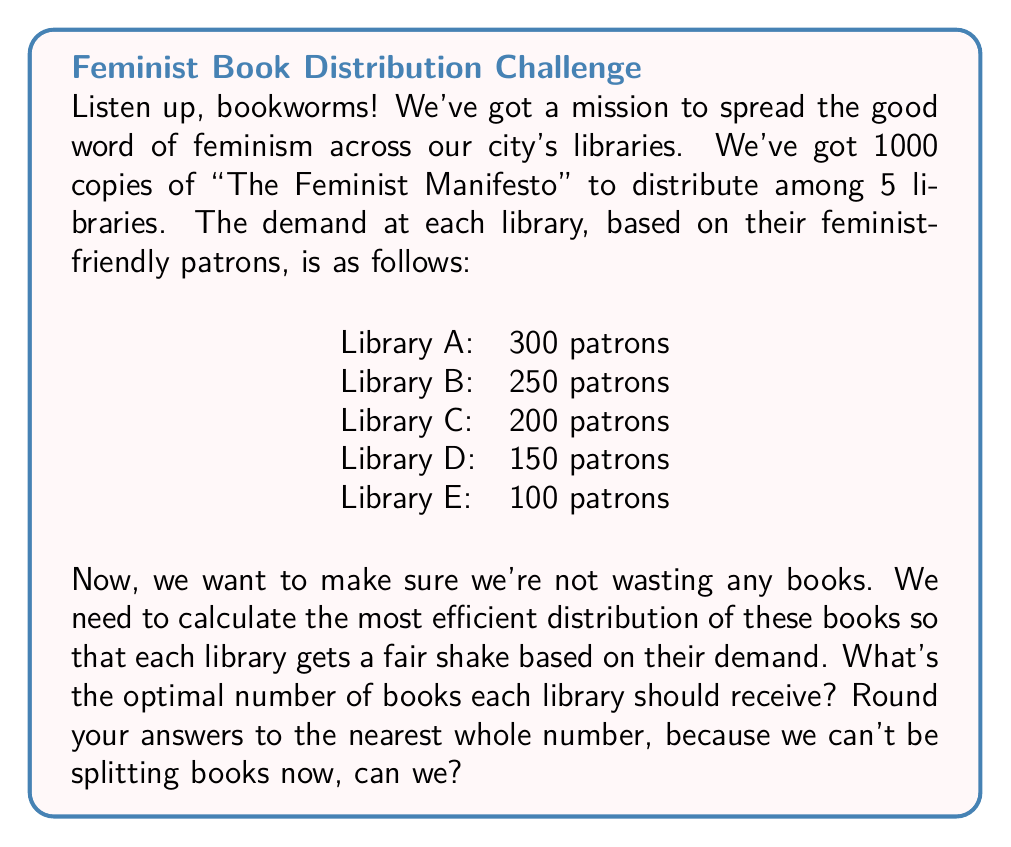Can you answer this question? Alright, let's break this down step by step:

1) First, we need to calculate the total number of patrons across all libraries:

   $300 + 250 + 200 + 150 + 100 = 1000$ patrons

2) Now, we need to determine what fraction of the total patron population each library represents. We'll do this by dividing each library's patron count by the total:

   Library A: $\frac{300}{1000} = 0.3$ or 30%
   Library B: $\frac{250}{1000} = 0.25$ or 25%
   Library C: $\frac{200}{1000} = 0.2$ or 20%
   Library D: $\frac{150}{1000} = 0.15$ or 15%
   Library E: $\frac{100}{1000} = 0.1$ or 10%

3) The most efficient distribution would be to allocate books in proportion to each library's share of the total patron population. We can calculate this by multiplying the total number of books (1000) by each library's fraction:

   Library A: $1000 \times 0.3 = 300$ books
   Library B: $1000 \times 0.25 = 250$ books
   Library C: $1000 \times 0.2 = 200$ books
   Library D: $1000 \times 0.15 = 150$ books
   Library E: $1000 \times 0.1 = 100$ books

4) We don't need to round these numbers because they all worked out to whole numbers. If they hadn't, we would round to the nearest whole number as requested.

5) Let's verify that our distribution adds up to the total number of books:

   $300 + 250 + 200 + 150 + 100 = 1000$ books

This distribution ensures that each library receives a number of books proportional to its demand, maximizing the efficiency of our feminist literature distribution!
Answer: The optimal distribution of books is:
Library A: 300 books
Library B: 250 books
Library C: 200 books
Library D: 150 books
Library E: 100 books 